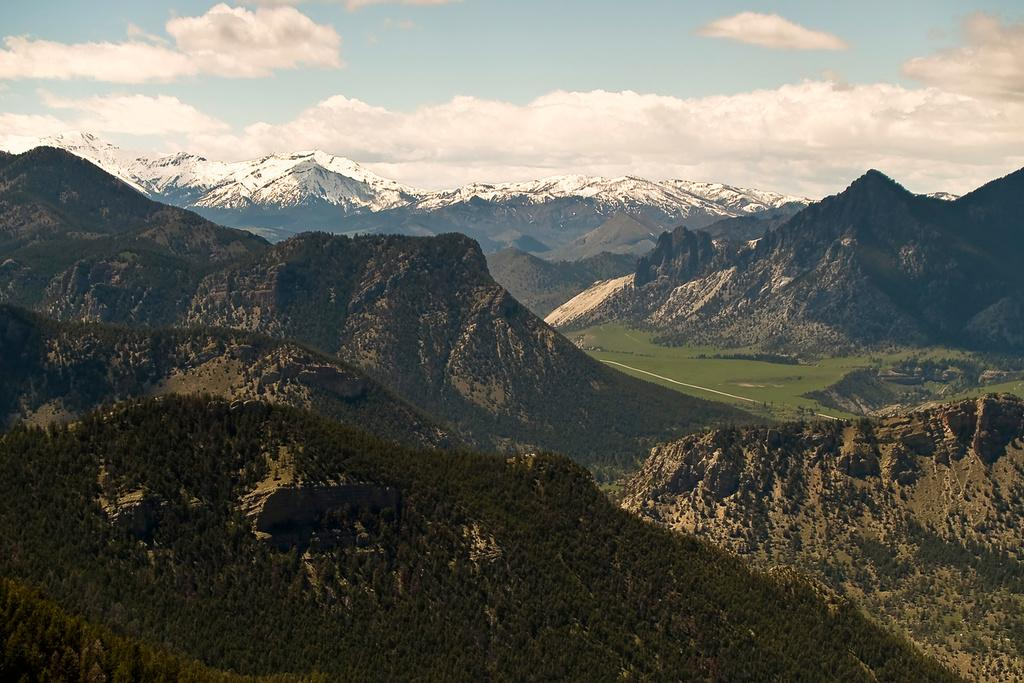What type of setting is depicted in the image? The image is an outside view. What natural elements can be seen in the image? There are many trees and mountains in the image. What is visible at the top of the image? The sky is visible at the top of the image. What can be observed in the sky? Clouds are present in the sky. What rule is being enforced by the trees in the image? There is no rule being enforced by the trees in the image; they are simply natural elements in the landscape. Can you hear the trees laughing in the image? There is no sound or laughter present in the image; it is a still photograph. 